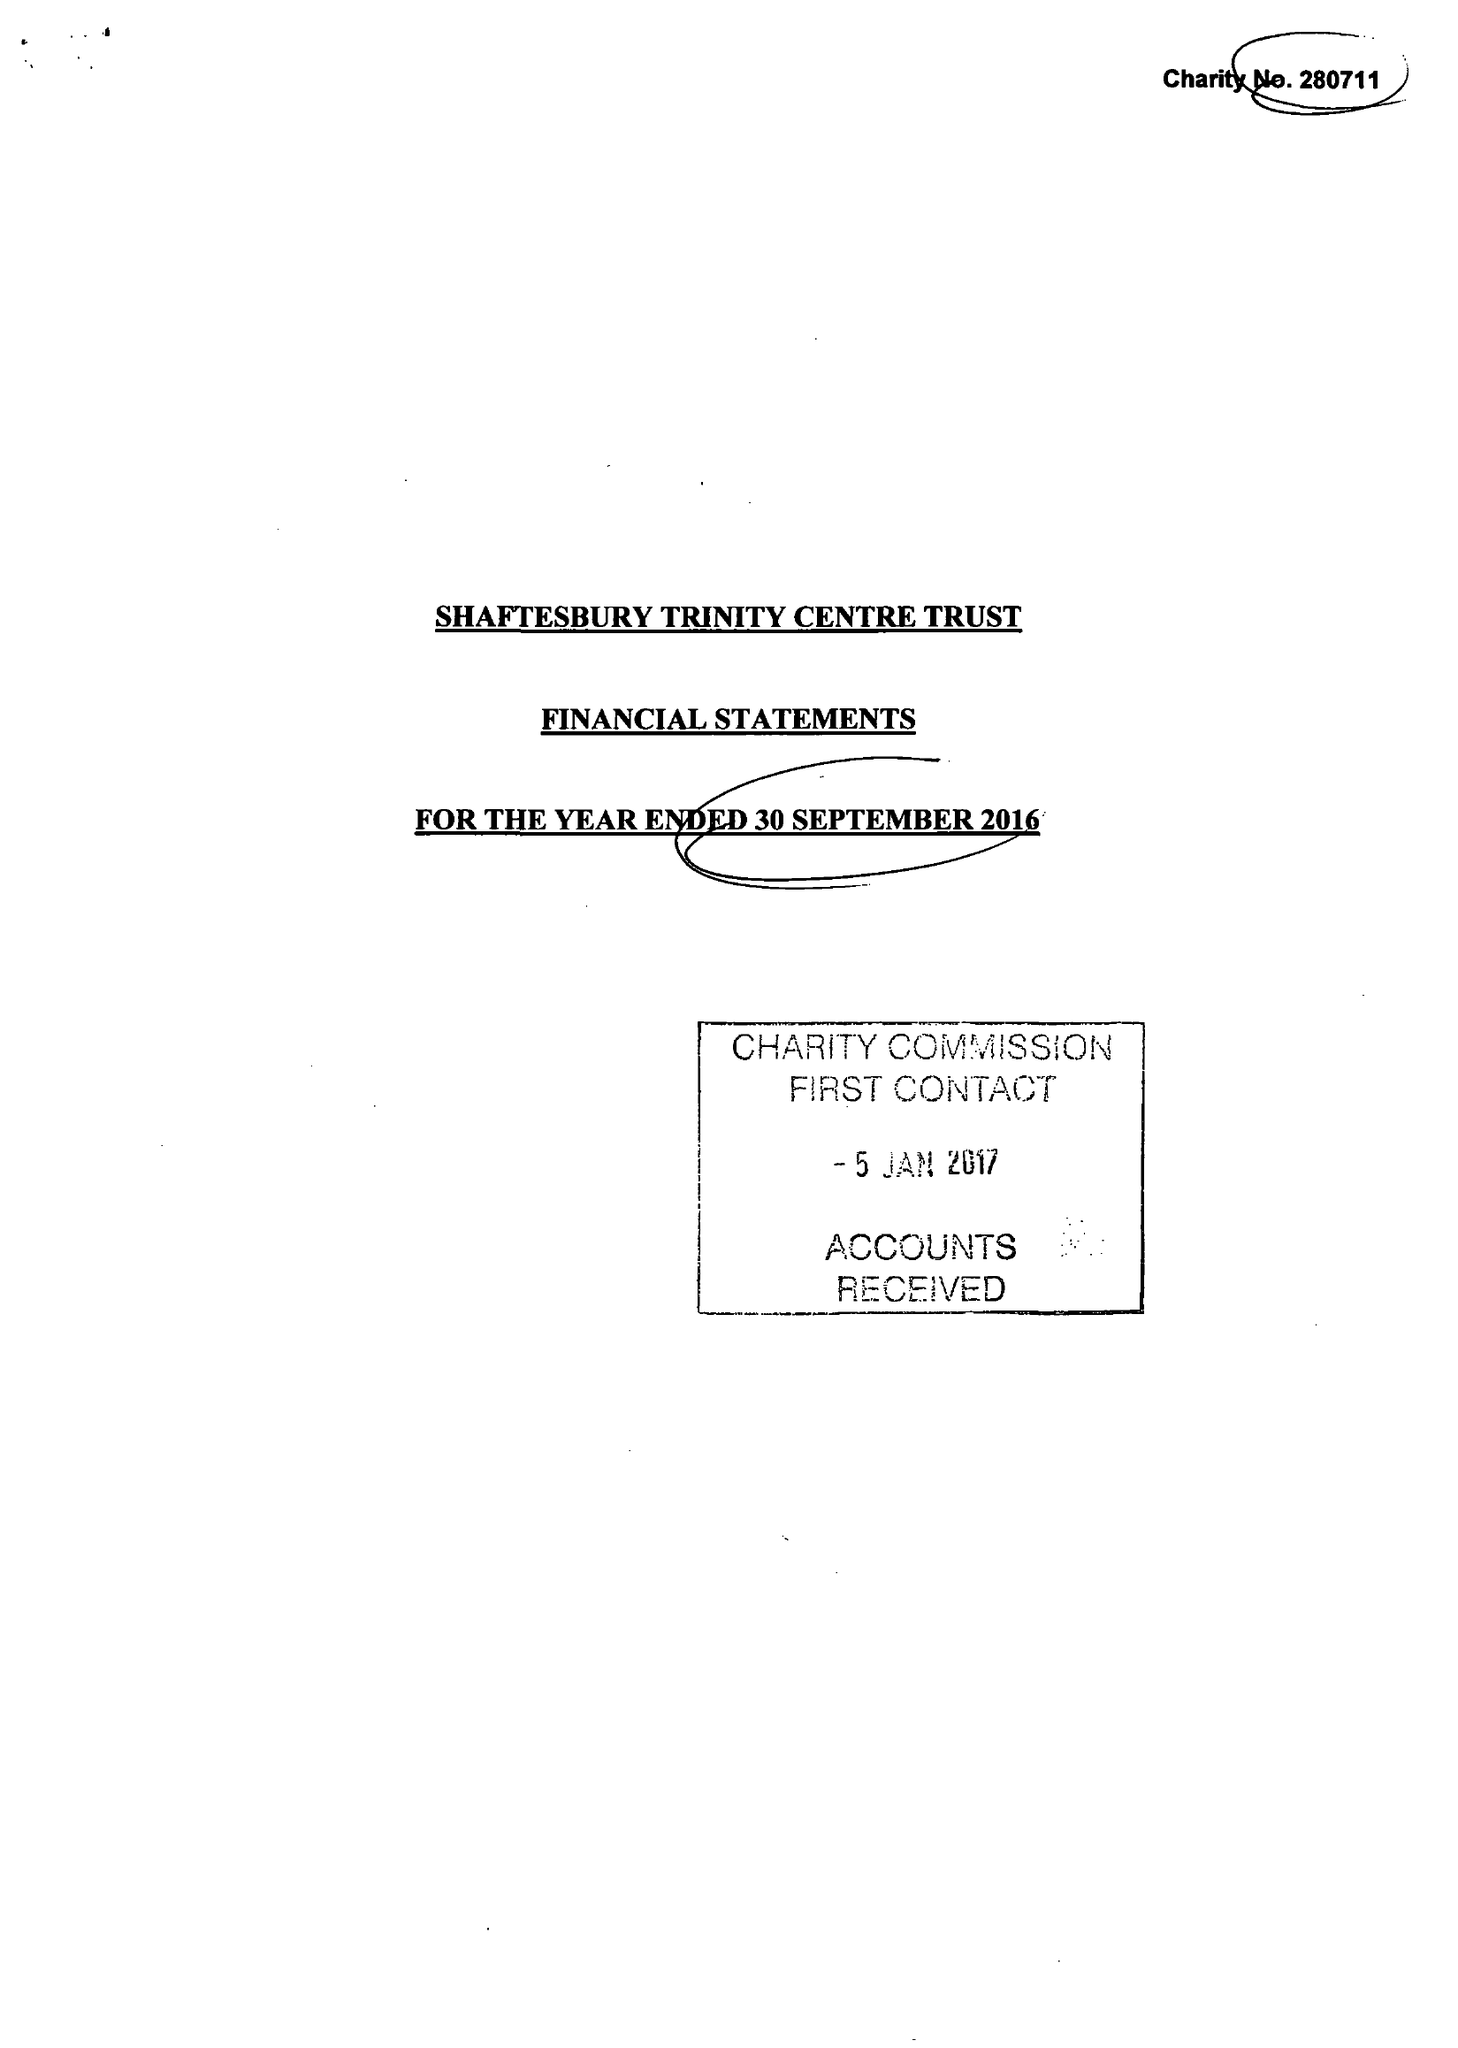What is the value for the address__postcode?
Answer the question using a single word or phrase. SP8 5JH 